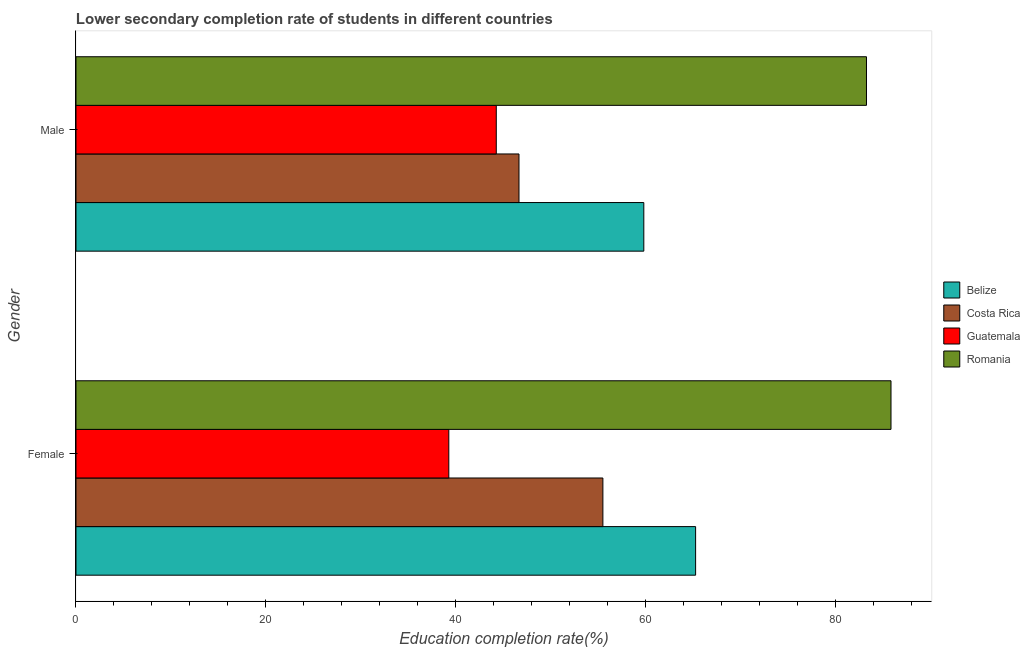What is the label of the 2nd group of bars from the top?
Your answer should be very brief. Female. What is the education completion rate of male students in Romania?
Provide a short and direct response. 83.29. Across all countries, what is the maximum education completion rate of male students?
Provide a short and direct response. 83.29. Across all countries, what is the minimum education completion rate of female students?
Offer a very short reply. 39.28. In which country was the education completion rate of female students maximum?
Offer a very short reply. Romania. In which country was the education completion rate of male students minimum?
Make the answer very short. Guatemala. What is the total education completion rate of male students in the graph?
Make the answer very short. 234.08. What is the difference between the education completion rate of male students in Costa Rica and that in Guatemala?
Ensure brevity in your answer.  2.39. What is the difference between the education completion rate of female students in Romania and the education completion rate of male students in Costa Rica?
Give a very brief answer. 39.2. What is the average education completion rate of male students per country?
Offer a terse response. 58.52. What is the difference between the education completion rate of female students and education completion rate of male students in Belize?
Offer a terse response. 5.46. In how many countries, is the education completion rate of male students greater than 32 %?
Offer a very short reply. 4. What is the ratio of the education completion rate of female students in Guatemala to that in Costa Rica?
Keep it short and to the point. 0.71. In how many countries, is the education completion rate of male students greater than the average education completion rate of male students taken over all countries?
Offer a terse response. 2. What does the 4th bar from the bottom in Female represents?
Make the answer very short. Romania. How many bars are there?
Make the answer very short. 8. Are all the bars in the graph horizontal?
Your answer should be very brief. Yes. What is the difference between two consecutive major ticks on the X-axis?
Offer a terse response. 20. Does the graph contain any zero values?
Make the answer very short. No. Does the graph contain grids?
Provide a succinct answer. No. Where does the legend appear in the graph?
Your answer should be very brief. Center right. How many legend labels are there?
Offer a terse response. 4. What is the title of the graph?
Make the answer very short. Lower secondary completion rate of students in different countries. What is the label or title of the X-axis?
Keep it short and to the point. Education completion rate(%). What is the label or title of the Y-axis?
Give a very brief answer. Gender. What is the Education completion rate(%) of Belize in Female?
Keep it short and to the point. 65.29. What is the Education completion rate(%) of Costa Rica in Female?
Provide a succinct answer. 55.52. What is the Education completion rate(%) in Guatemala in Female?
Offer a terse response. 39.28. What is the Education completion rate(%) of Romania in Female?
Offer a very short reply. 85.88. What is the Education completion rate(%) of Belize in Male?
Provide a short and direct response. 59.83. What is the Education completion rate(%) of Costa Rica in Male?
Offer a terse response. 46.68. What is the Education completion rate(%) in Guatemala in Male?
Provide a short and direct response. 44.28. What is the Education completion rate(%) in Romania in Male?
Give a very brief answer. 83.29. Across all Gender, what is the maximum Education completion rate(%) in Belize?
Provide a short and direct response. 65.29. Across all Gender, what is the maximum Education completion rate(%) of Costa Rica?
Your response must be concise. 55.52. Across all Gender, what is the maximum Education completion rate(%) in Guatemala?
Your answer should be very brief. 44.28. Across all Gender, what is the maximum Education completion rate(%) of Romania?
Keep it short and to the point. 85.88. Across all Gender, what is the minimum Education completion rate(%) of Belize?
Make the answer very short. 59.83. Across all Gender, what is the minimum Education completion rate(%) in Costa Rica?
Your response must be concise. 46.68. Across all Gender, what is the minimum Education completion rate(%) in Guatemala?
Your answer should be compact. 39.28. Across all Gender, what is the minimum Education completion rate(%) of Romania?
Keep it short and to the point. 83.29. What is the total Education completion rate(%) of Belize in the graph?
Give a very brief answer. 125.12. What is the total Education completion rate(%) in Costa Rica in the graph?
Make the answer very short. 102.19. What is the total Education completion rate(%) in Guatemala in the graph?
Your answer should be compact. 83.57. What is the total Education completion rate(%) of Romania in the graph?
Give a very brief answer. 169.17. What is the difference between the Education completion rate(%) of Belize in Female and that in Male?
Give a very brief answer. 5.46. What is the difference between the Education completion rate(%) of Costa Rica in Female and that in Male?
Make the answer very short. 8.84. What is the difference between the Education completion rate(%) of Guatemala in Female and that in Male?
Make the answer very short. -5. What is the difference between the Education completion rate(%) in Romania in Female and that in Male?
Keep it short and to the point. 2.58. What is the difference between the Education completion rate(%) of Belize in Female and the Education completion rate(%) of Costa Rica in Male?
Offer a very short reply. 18.61. What is the difference between the Education completion rate(%) of Belize in Female and the Education completion rate(%) of Guatemala in Male?
Give a very brief answer. 21. What is the difference between the Education completion rate(%) in Belize in Female and the Education completion rate(%) in Romania in Male?
Offer a very short reply. -18. What is the difference between the Education completion rate(%) in Costa Rica in Female and the Education completion rate(%) in Guatemala in Male?
Ensure brevity in your answer.  11.23. What is the difference between the Education completion rate(%) in Costa Rica in Female and the Education completion rate(%) in Romania in Male?
Your answer should be compact. -27.77. What is the difference between the Education completion rate(%) in Guatemala in Female and the Education completion rate(%) in Romania in Male?
Your answer should be compact. -44.01. What is the average Education completion rate(%) in Belize per Gender?
Your answer should be compact. 62.56. What is the average Education completion rate(%) in Costa Rica per Gender?
Provide a short and direct response. 51.1. What is the average Education completion rate(%) in Guatemala per Gender?
Keep it short and to the point. 41.78. What is the average Education completion rate(%) in Romania per Gender?
Your response must be concise. 84.58. What is the difference between the Education completion rate(%) of Belize and Education completion rate(%) of Costa Rica in Female?
Offer a terse response. 9.77. What is the difference between the Education completion rate(%) of Belize and Education completion rate(%) of Guatemala in Female?
Provide a succinct answer. 26. What is the difference between the Education completion rate(%) in Belize and Education completion rate(%) in Romania in Female?
Keep it short and to the point. -20.59. What is the difference between the Education completion rate(%) of Costa Rica and Education completion rate(%) of Guatemala in Female?
Offer a very short reply. 16.23. What is the difference between the Education completion rate(%) of Costa Rica and Education completion rate(%) of Romania in Female?
Ensure brevity in your answer.  -30.36. What is the difference between the Education completion rate(%) of Guatemala and Education completion rate(%) of Romania in Female?
Give a very brief answer. -46.59. What is the difference between the Education completion rate(%) of Belize and Education completion rate(%) of Costa Rica in Male?
Offer a terse response. 13.15. What is the difference between the Education completion rate(%) in Belize and Education completion rate(%) in Guatemala in Male?
Your answer should be compact. 15.54. What is the difference between the Education completion rate(%) of Belize and Education completion rate(%) of Romania in Male?
Give a very brief answer. -23.46. What is the difference between the Education completion rate(%) in Costa Rica and Education completion rate(%) in Guatemala in Male?
Your response must be concise. 2.39. What is the difference between the Education completion rate(%) in Costa Rica and Education completion rate(%) in Romania in Male?
Keep it short and to the point. -36.61. What is the difference between the Education completion rate(%) in Guatemala and Education completion rate(%) in Romania in Male?
Your response must be concise. -39.01. What is the ratio of the Education completion rate(%) of Belize in Female to that in Male?
Provide a succinct answer. 1.09. What is the ratio of the Education completion rate(%) of Costa Rica in Female to that in Male?
Keep it short and to the point. 1.19. What is the ratio of the Education completion rate(%) in Guatemala in Female to that in Male?
Offer a very short reply. 0.89. What is the ratio of the Education completion rate(%) of Romania in Female to that in Male?
Your response must be concise. 1.03. What is the difference between the highest and the second highest Education completion rate(%) of Belize?
Give a very brief answer. 5.46. What is the difference between the highest and the second highest Education completion rate(%) of Costa Rica?
Provide a succinct answer. 8.84. What is the difference between the highest and the second highest Education completion rate(%) of Guatemala?
Offer a terse response. 5. What is the difference between the highest and the second highest Education completion rate(%) of Romania?
Make the answer very short. 2.58. What is the difference between the highest and the lowest Education completion rate(%) of Belize?
Your answer should be compact. 5.46. What is the difference between the highest and the lowest Education completion rate(%) in Costa Rica?
Your answer should be compact. 8.84. What is the difference between the highest and the lowest Education completion rate(%) in Guatemala?
Provide a short and direct response. 5. What is the difference between the highest and the lowest Education completion rate(%) in Romania?
Give a very brief answer. 2.58. 